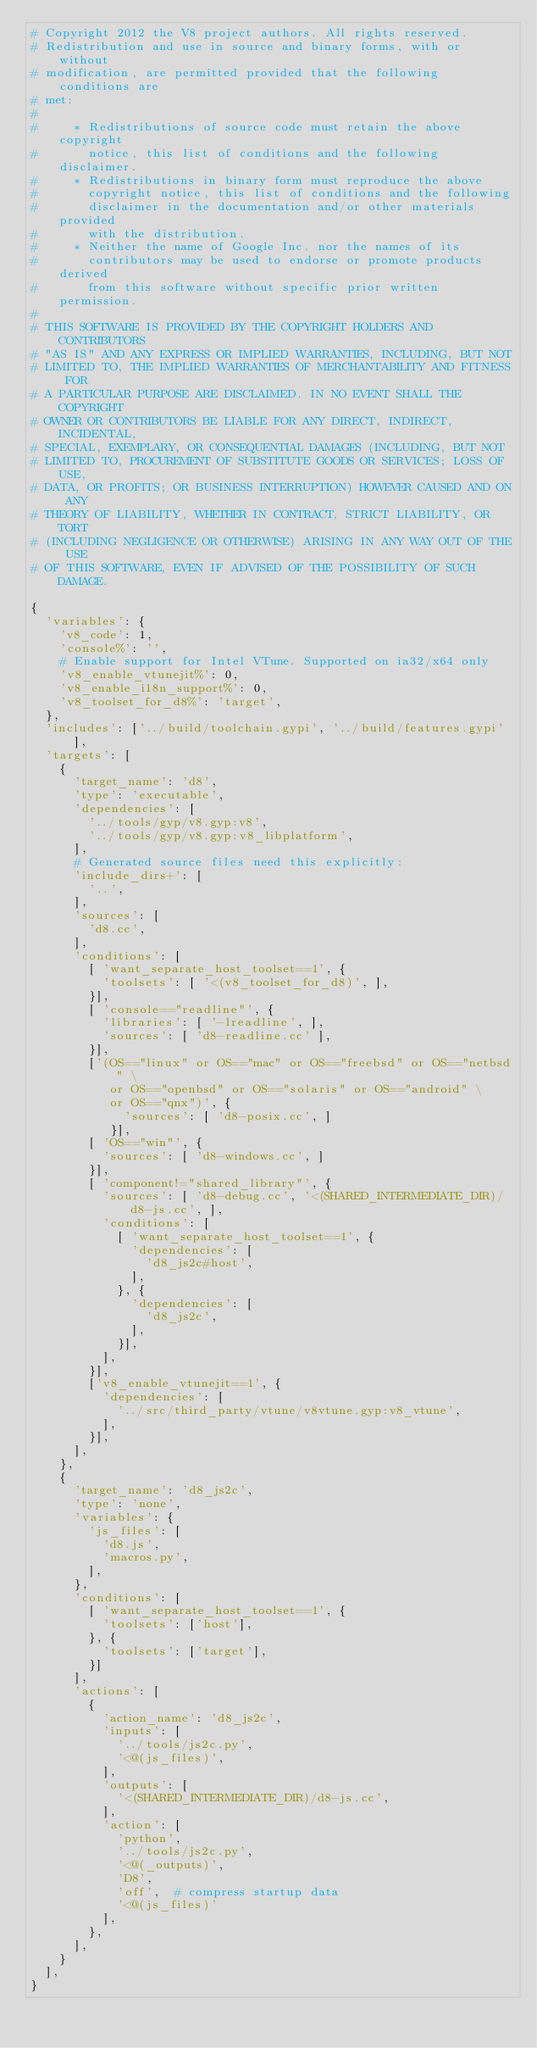<code> <loc_0><loc_0><loc_500><loc_500><_Python_># Copyright 2012 the V8 project authors. All rights reserved.
# Redistribution and use in source and binary forms, with or without
# modification, are permitted provided that the following conditions are
# met:
#
#     * Redistributions of source code must retain the above copyright
#       notice, this list of conditions and the following disclaimer.
#     * Redistributions in binary form must reproduce the above
#       copyright notice, this list of conditions and the following
#       disclaimer in the documentation and/or other materials provided
#       with the distribution.
#     * Neither the name of Google Inc. nor the names of its
#       contributors may be used to endorse or promote products derived
#       from this software without specific prior written permission.
#
# THIS SOFTWARE IS PROVIDED BY THE COPYRIGHT HOLDERS AND CONTRIBUTORS
# "AS IS" AND ANY EXPRESS OR IMPLIED WARRANTIES, INCLUDING, BUT NOT
# LIMITED TO, THE IMPLIED WARRANTIES OF MERCHANTABILITY AND FITNESS FOR
# A PARTICULAR PURPOSE ARE DISCLAIMED. IN NO EVENT SHALL THE COPYRIGHT
# OWNER OR CONTRIBUTORS BE LIABLE FOR ANY DIRECT, INDIRECT, INCIDENTAL,
# SPECIAL, EXEMPLARY, OR CONSEQUENTIAL DAMAGES (INCLUDING, BUT NOT
# LIMITED TO, PROCUREMENT OF SUBSTITUTE GOODS OR SERVICES; LOSS OF USE,
# DATA, OR PROFITS; OR BUSINESS INTERRUPTION) HOWEVER CAUSED AND ON ANY
# THEORY OF LIABILITY, WHETHER IN CONTRACT, STRICT LIABILITY, OR TORT
# (INCLUDING NEGLIGENCE OR OTHERWISE) ARISING IN ANY WAY OUT OF THE USE
# OF THIS SOFTWARE, EVEN IF ADVISED OF THE POSSIBILITY OF SUCH DAMAGE.

{
  'variables': {
    'v8_code': 1,
    'console%': '',
    # Enable support for Intel VTune. Supported on ia32/x64 only
    'v8_enable_vtunejit%': 0,
    'v8_enable_i18n_support%': 0,
    'v8_toolset_for_d8%': 'target',
  },
  'includes': ['../build/toolchain.gypi', '../build/features.gypi'],
  'targets': [
    {
      'target_name': 'd8',
      'type': 'executable',
      'dependencies': [
        '../tools/gyp/v8.gyp:v8',
        '../tools/gyp/v8.gyp:v8_libplatform',
      ],
      # Generated source files need this explicitly:
      'include_dirs+': [
        '..',
      ],
      'sources': [
        'd8.cc',
      ],
      'conditions': [
        [ 'want_separate_host_toolset==1', {
          'toolsets': [ '<(v8_toolset_for_d8)', ],
        }],
        [ 'console=="readline"', {
          'libraries': [ '-lreadline', ],
          'sources': [ 'd8-readline.cc' ],
        }],
        ['(OS=="linux" or OS=="mac" or OS=="freebsd" or OS=="netbsd" \
           or OS=="openbsd" or OS=="solaris" or OS=="android" \
           or OS=="qnx")', {
             'sources': [ 'd8-posix.cc', ]
           }],
        [ 'OS=="win"', {
          'sources': [ 'd8-windows.cc', ]
        }],
        [ 'component!="shared_library"', {
          'sources': [ 'd8-debug.cc', '<(SHARED_INTERMEDIATE_DIR)/d8-js.cc', ],
          'conditions': [
            [ 'want_separate_host_toolset==1', {
              'dependencies': [
                'd8_js2c#host',
              ],
            }, {
              'dependencies': [
                'd8_js2c',
              ],
            }],
          ],
        }],
        ['v8_enable_vtunejit==1', {
          'dependencies': [
            '../src/third_party/vtune/v8vtune.gyp:v8_vtune',
          ],
        }],
      ],
    },
    {
      'target_name': 'd8_js2c',
      'type': 'none',
      'variables': {
        'js_files': [
          'd8.js',
          'macros.py',
        ],
      },
      'conditions': [
        [ 'want_separate_host_toolset==1', {
          'toolsets': ['host'],
        }, {
          'toolsets': ['target'],
        }]
      ],
      'actions': [
        {
          'action_name': 'd8_js2c',
          'inputs': [
            '../tools/js2c.py',
            '<@(js_files)',
          ],
          'outputs': [
            '<(SHARED_INTERMEDIATE_DIR)/d8-js.cc',
          ],
          'action': [
            'python',
            '../tools/js2c.py',
            '<@(_outputs)',
            'D8',
            'off',  # compress startup data
            '<@(js_files)'
          ],
        },
      ],
    }
  ],
}
</code> 